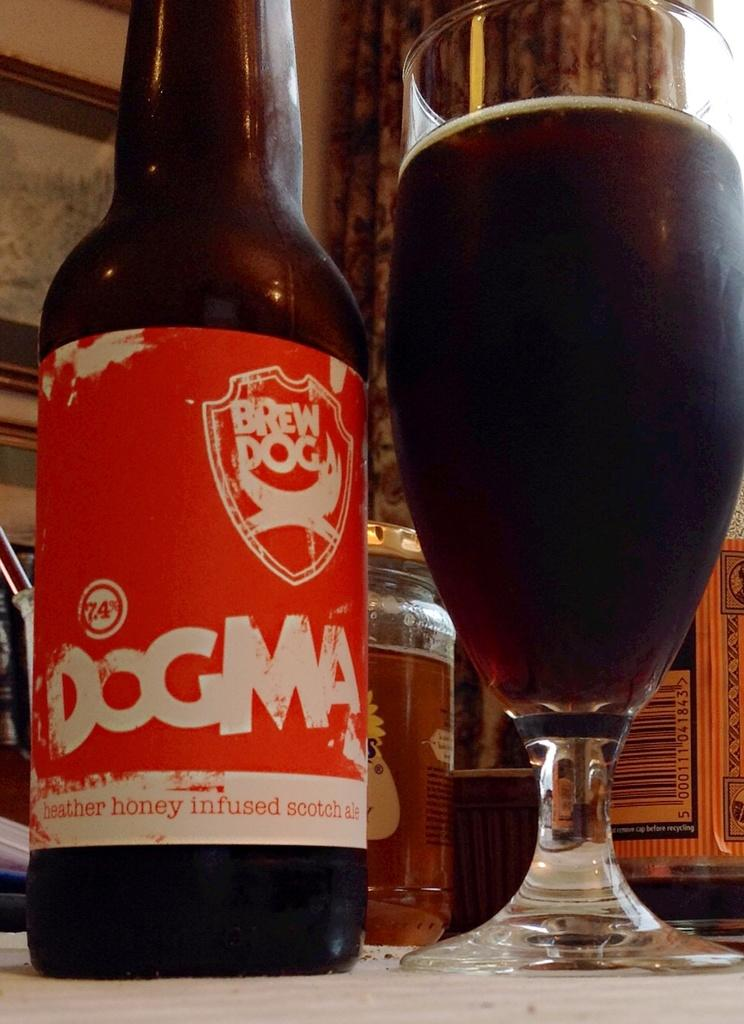<image>
Provide a brief description of the given image. A glass of dark beer sits next to a bottle of Brew Dog ale. 